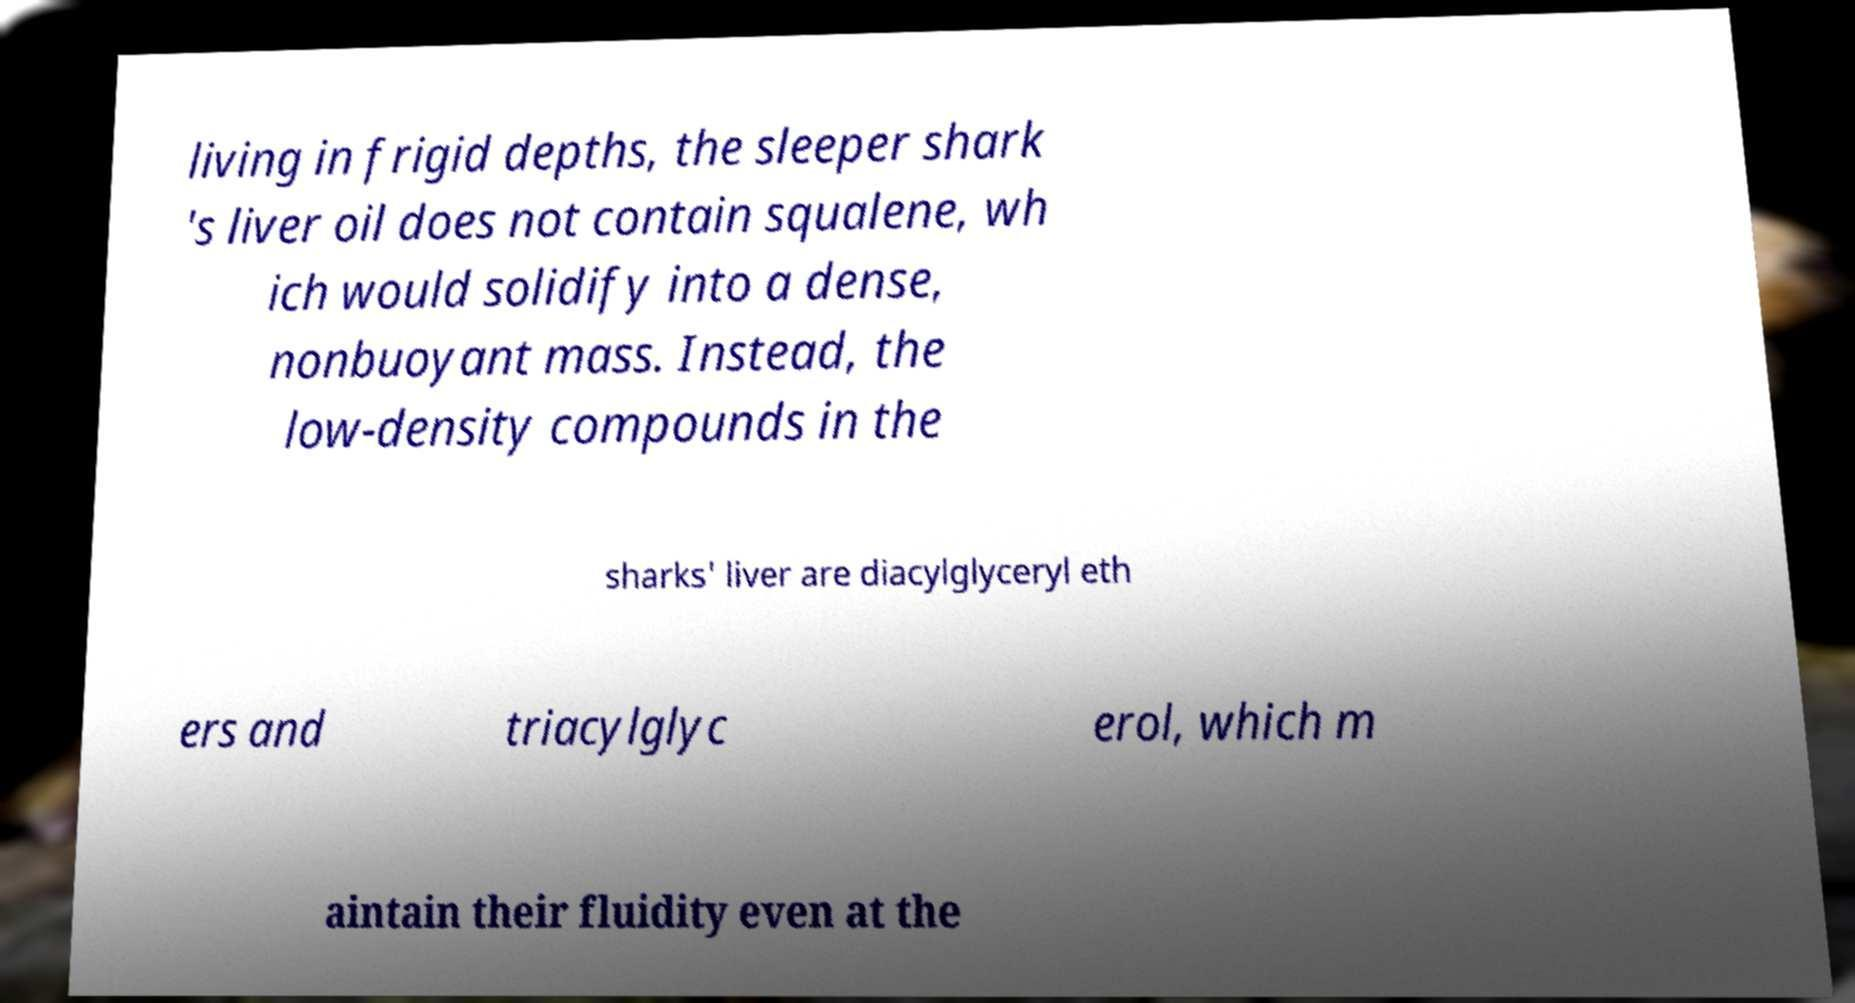There's text embedded in this image that I need extracted. Can you transcribe it verbatim? living in frigid depths, the sleeper shark 's liver oil does not contain squalene, wh ich would solidify into a dense, nonbuoyant mass. Instead, the low-density compounds in the sharks' liver are diacylglyceryl eth ers and triacylglyc erol, which m aintain their fluidity even at the 